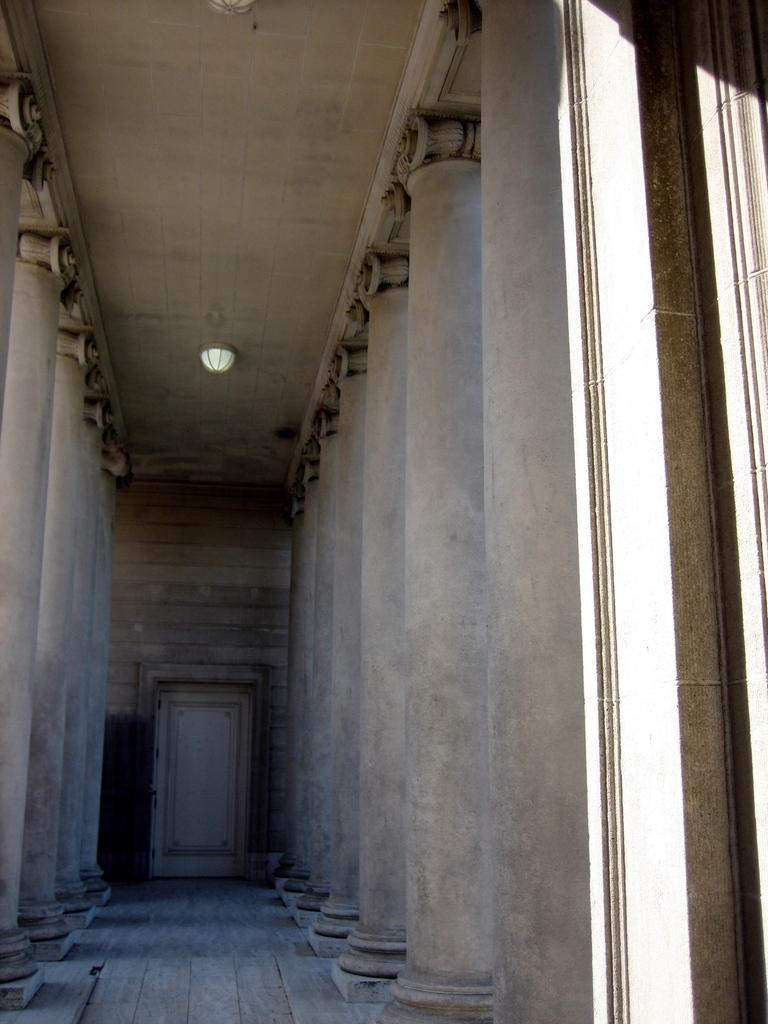What type of surface is visible in the image? There is a floor in the image. What architectural elements can be seen in the image? There are pillars, a door, and a wall visible in the image. What is the lighting condition in the image? The background of the image includes light. What is above the floor in the image? There is a ceiling visible in the image. How many locks are visible on the door in the image? There are no locks visible on the door in the image. What type of lumber is being transported in the image? There is no lumber or transportation activity present in the image. 